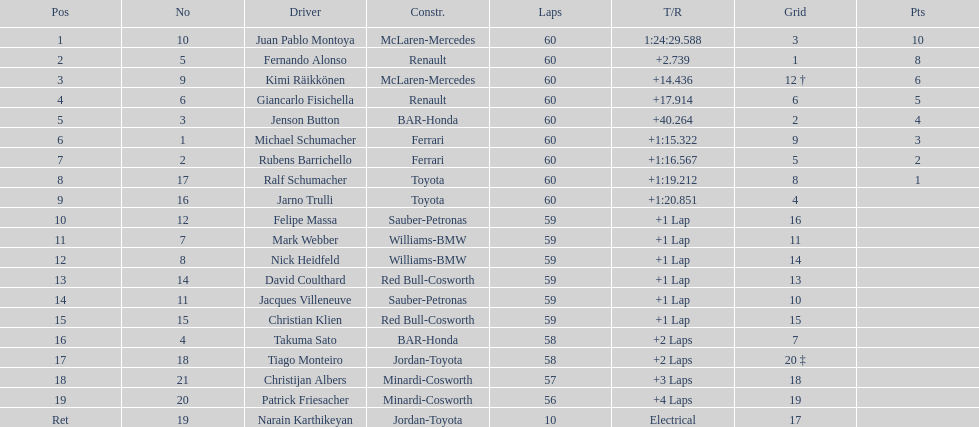Which driver has the least amount of points? Ralf Schumacher. 